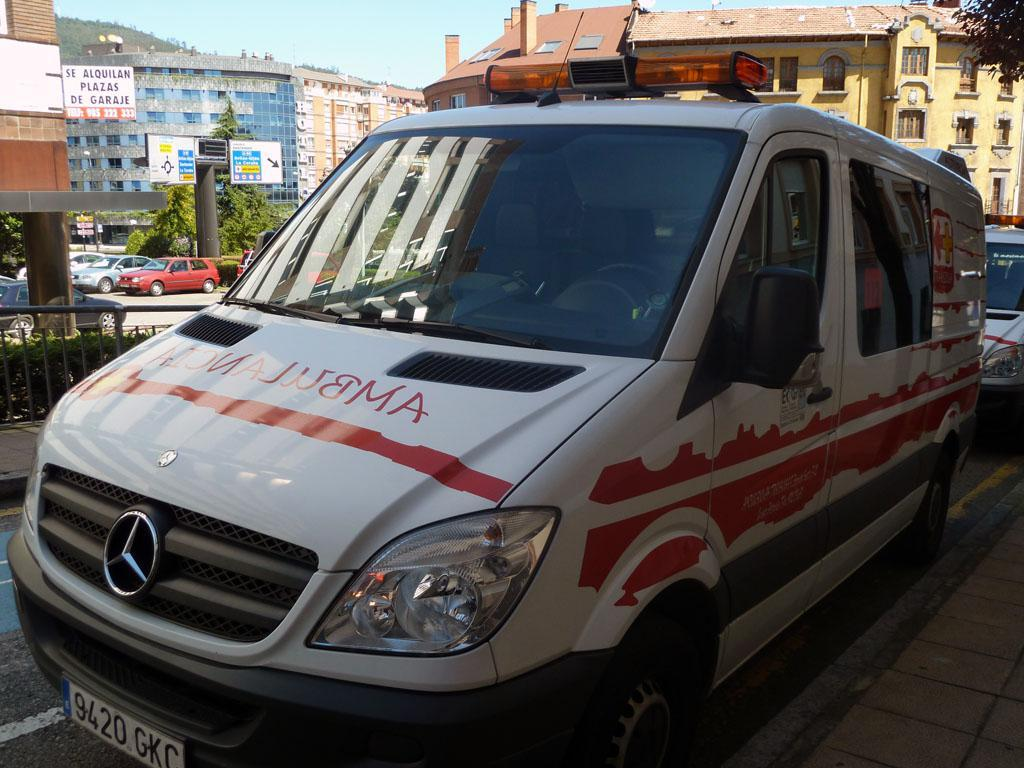<image>
Offer a succinct explanation of the picture presented. a white and red Ambulance is on the road 